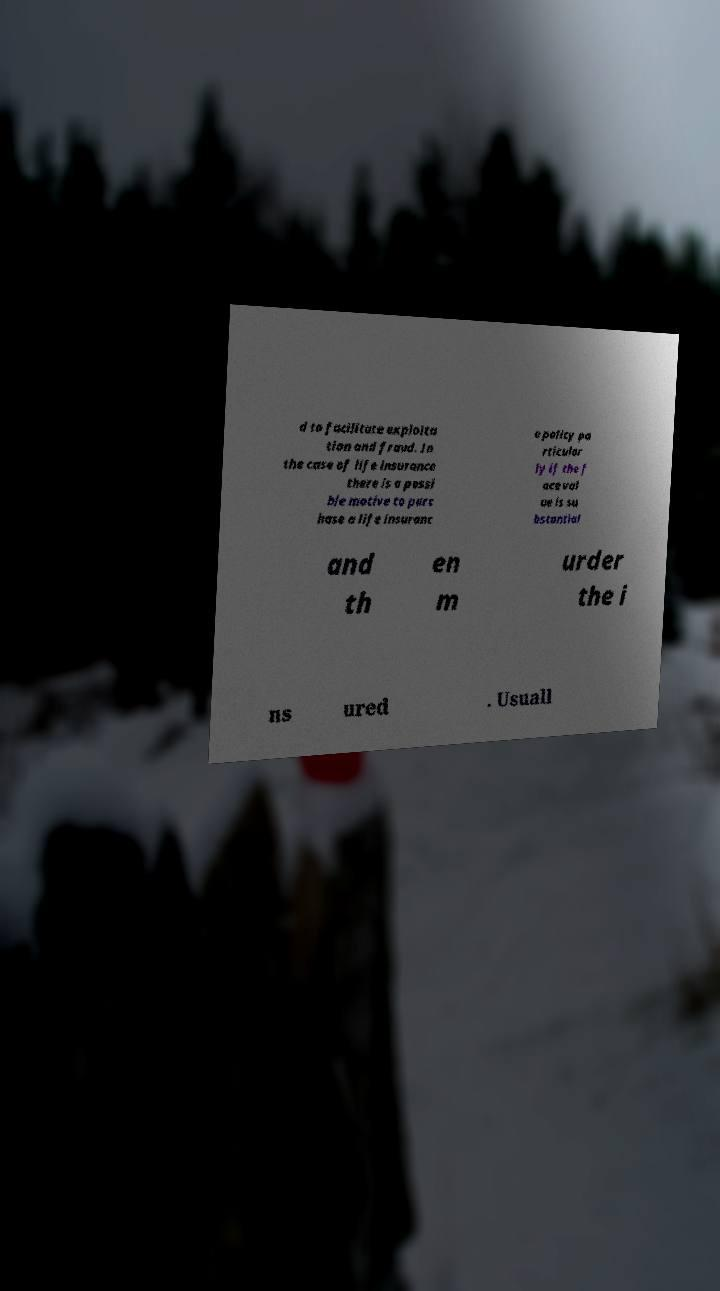Please identify and transcribe the text found in this image. d to facilitate exploita tion and fraud. In the case of life insurance there is a possi ble motive to purc hase a life insuranc e policy pa rticular ly if the f ace val ue is su bstantial and th en m urder the i ns ured . Usuall 